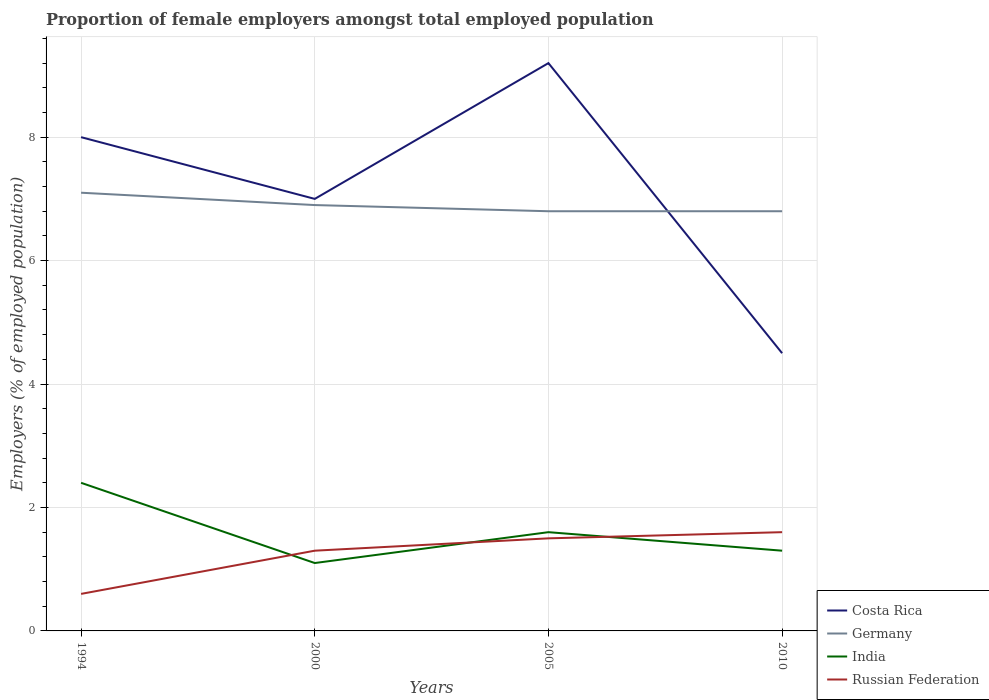How many different coloured lines are there?
Your answer should be compact. 4. Does the line corresponding to Costa Rica intersect with the line corresponding to Russian Federation?
Your response must be concise. No. Across all years, what is the maximum proportion of female employers in Costa Rica?
Ensure brevity in your answer.  4.5. In which year was the proportion of female employers in Germany maximum?
Your answer should be very brief. 2005. What is the total proportion of female employers in Russian Federation in the graph?
Your answer should be compact. -0.1. What is the difference between the highest and the second highest proportion of female employers in Germany?
Give a very brief answer. 0.3. Is the proportion of female employers in Russian Federation strictly greater than the proportion of female employers in Costa Rica over the years?
Offer a very short reply. Yes. How many lines are there?
Keep it short and to the point. 4. How many years are there in the graph?
Keep it short and to the point. 4. Are the values on the major ticks of Y-axis written in scientific E-notation?
Your answer should be compact. No. Does the graph contain any zero values?
Offer a terse response. No. Does the graph contain grids?
Provide a short and direct response. Yes. How many legend labels are there?
Your answer should be compact. 4. How are the legend labels stacked?
Your response must be concise. Vertical. What is the title of the graph?
Offer a very short reply. Proportion of female employers amongst total employed population. Does "Belarus" appear as one of the legend labels in the graph?
Your response must be concise. No. What is the label or title of the X-axis?
Your response must be concise. Years. What is the label or title of the Y-axis?
Make the answer very short. Employers (% of employed population). What is the Employers (% of employed population) in Costa Rica in 1994?
Your answer should be compact. 8. What is the Employers (% of employed population) of Germany in 1994?
Make the answer very short. 7.1. What is the Employers (% of employed population) in India in 1994?
Ensure brevity in your answer.  2.4. What is the Employers (% of employed population) of Russian Federation in 1994?
Offer a terse response. 0.6. What is the Employers (% of employed population) in Costa Rica in 2000?
Keep it short and to the point. 7. What is the Employers (% of employed population) of Germany in 2000?
Give a very brief answer. 6.9. What is the Employers (% of employed population) in India in 2000?
Give a very brief answer. 1.1. What is the Employers (% of employed population) of Russian Federation in 2000?
Keep it short and to the point. 1.3. What is the Employers (% of employed population) of Costa Rica in 2005?
Make the answer very short. 9.2. What is the Employers (% of employed population) of Germany in 2005?
Provide a short and direct response. 6.8. What is the Employers (% of employed population) of India in 2005?
Provide a short and direct response. 1.6. What is the Employers (% of employed population) of Russian Federation in 2005?
Your response must be concise. 1.5. What is the Employers (% of employed population) of Costa Rica in 2010?
Keep it short and to the point. 4.5. What is the Employers (% of employed population) of Germany in 2010?
Your response must be concise. 6.8. What is the Employers (% of employed population) of India in 2010?
Offer a very short reply. 1.3. What is the Employers (% of employed population) in Russian Federation in 2010?
Provide a succinct answer. 1.6. Across all years, what is the maximum Employers (% of employed population) in Costa Rica?
Ensure brevity in your answer.  9.2. Across all years, what is the maximum Employers (% of employed population) in Germany?
Provide a short and direct response. 7.1. Across all years, what is the maximum Employers (% of employed population) in India?
Provide a succinct answer. 2.4. Across all years, what is the maximum Employers (% of employed population) of Russian Federation?
Make the answer very short. 1.6. Across all years, what is the minimum Employers (% of employed population) of Germany?
Offer a very short reply. 6.8. Across all years, what is the minimum Employers (% of employed population) of India?
Make the answer very short. 1.1. Across all years, what is the minimum Employers (% of employed population) of Russian Federation?
Make the answer very short. 0.6. What is the total Employers (% of employed population) in Costa Rica in the graph?
Provide a succinct answer. 28.7. What is the total Employers (% of employed population) in Germany in the graph?
Ensure brevity in your answer.  27.6. What is the difference between the Employers (% of employed population) in Costa Rica in 1994 and that in 2000?
Keep it short and to the point. 1. What is the difference between the Employers (% of employed population) of Germany in 1994 and that in 2000?
Your response must be concise. 0.2. What is the difference between the Employers (% of employed population) in Costa Rica in 1994 and that in 2005?
Your answer should be very brief. -1.2. What is the difference between the Employers (% of employed population) in Germany in 1994 and that in 2005?
Keep it short and to the point. 0.3. What is the difference between the Employers (% of employed population) of India in 1994 and that in 2005?
Keep it short and to the point. 0.8. What is the difference between the Employers (% of employed population) of Germany in 1994 and that in 2010?
Make the answer very short. 0.3. What is the difference between the Employers (% of employed population) of Russian Federation in 1994 and that in 2010?
Your answer should be compact. -1. What is the difference between the Employers (% of employed population) of Costa Rica in 2000 and that in 2005?
Your answer should be compact. -2.2. What is the difference between the Employers (% of employed population) in Germany in 2000 and that in 2005?
Your answer should be compact. 0.1. What is the difference between the Employers (% of employed population) in Russian Federation in 2000 and that in 2005?
Your response must be concise. -0.2. What is the difference between the Employers (% of employed population) in Costa Rica in 2000 and that in 2010?
Offer a terse response. 2.5. What is the difference between the Employers (% of employed population) of India in 2000 and that in 2010?
Your answer should be very brief. -0.2. What is the difference between the Employers (% of employed population) of Costa Rica in 2005 and that in 2010?
Make the answer very short. 4.7. What is the difference between the Employers (% of employed population) of Germany in 2005 and that in 2010?
Offer a very short reply. 0. What is the difference between the Employers (% of employed population) in India in 2005 and that in 2010?
Offer a terse response. 0.3. What is the difference between the Employers (% of employed population) in Russian Federation in 2005 and that in 2010?
Provide a short and direct response. -0.1. What is the difference between the Employers (% of employed population) of Germany in 1994 and the Employers (% of employed population) of India in 2000?
Provide a short and direct response. 6. What is the difference between the Employers (% of employed population) of India in 1994 and the Employers (% of employed population) of Russian Federation in 2000?
Offer a terse response. 1.1. What is the difference between the Employers (% of employed population) of Costa Rica in 1994 and the Employers (% of employed population) of Germany in 2005?
Offer a terse response. 1.2. What is the difference between the Employers (% of employed population) in Germany in 1994 and the Employers (% of employed population) in India in 2005?
Keep it short and to the point. 5.5. What is the difference between the Employers (% of employed population) in India in 1994 and the Employers (% of employed population) in Russian Federation in 2005?
Offer a terse response. 0.9. What is the difference between the Employers (% of employed population) in Costa Rica in 2000 and the Employers (% of employed population) in Germany in 2005?
Offer a very short reply. 0.2. What is the difference between the Employers (% of employed population) in Costa Rica in 2000 and the Employers (% of employed population) in India in 2005?
Your answer should be very brief. 5.4. What is the difference between the Employers (% of employed population) of Costa Rica in 2000 and the Employers (% of employed population) of Russian Federation in 2005?
Your answer should be very brief. 5.5. What is the difference between the Employers (% of employed population) in Germany in 2000 and the Employers (% of employed population) in Russian Federation in 2010?
Make the answer very short. 5.3. What is the difference between the Employers (% of employed population) of India in 2000 and the Employers (% of employed population) of Russian Federation in 2010?
Give a very brief answer. -0.5. What is the difference between the Employers (% of employed population) of Germany in 2005 and the Employers (% of employed population) of Russian Federation in 2010?
Provide a short and direct response. 5.2. What is the average Employers (% of employed population) of Costa Rica per year?
Provide a short and direct response. 7.17. What is the average Employers (% of employed population) in India per year?
Keep it short and to the point. 1.6. In the year 1994, what is the difference between the Employers (% of employed population) in Costa Rica and Employers (% of employed population) in Germany?
Your response must be concise. 0.9. In the year 1994, what is the difference between the Employers (% of employed population) of Costa Rica and Employers (% of employed population) of India?
Keep it short and to the point. 5.6. In the year 1994, what is the difference between the Employers (% of employed population) of Germany and Employers (% of employed population) of India?
Your response must be concise. 4.7. In the year 1994, what is the difference between the Employers (% of employed population) of India and Employers (% of employed population) of Russian Federation?
Give a very brief answer. 1.8. In the year 2000, what is the difference between the Employers (% of employed population) in Costa Rica and Employers (% of employed population) in Russian Federation?
Provide a succinct answer. 5.7. In the year 2000, what is the difference between the Employers (% of employed population) in Germany and Employers (% of employed population) in Russian Federation?
Offer a very short reply. 5.6. In the year 2000, what is the difference between the Employers (% of employed population) in India and Employers (% of employed population) in Russian Federation?
Give a very brief answer. -0.2. In the year 2005, what is the difference between the Employers (% of employed population) of Costa Rica and Employers (% of employed population) of Russian Federation?
Offer a terse response. 7.7. In the year 2005, what is the difference between the Employers (% of employed population) in Germany and Employers (% of employed population) in Russian Federation?
Give a very brief answer. 5.3. In the year 2010, what is the difference between the Employers (% of employed population) in Costa Rica and Employers (% of employed population) in India?
Provide a succinct answer. 3.2. In the year 2010, what is the difference between the Employers (% of employed population) of Germany and Employers (% of employed population) of India?
Your response must be concise. 5.5. In the year 2010, what is the difference between the Employers (% of employed population) in Germany and Employers (% of employed population) in Russian Federation?
Provide a short and direct response. 5.2. In the year 2010, what is the difference between the Employers (% of employed population) in India and Employers (% of employed population) in Russian Federation?
Give a very brief answer. -0.3. What is the ratio of the Employers (% of employed population) of Germany in 1994 to that in 2000?
Ensure brevity in your answer.  1.03. What is the ratio of the Employers (% of employed population) of India in 1994 to that in 2000?
Ensure brevity in your answer.  2.18. What is the ratio of the Employers (% of employed population) in Russian Federation in 1994 to that in 2000?
Keep it short and to the point. 0.46. What is the ratio of the Employers (% of employed population) in Costa Rica in 1994 to that in 2005?
Offer a very short reply. 0.87. What is the ratio of the Employers (% of employed population) in Germany in 1994 to that in 2005?
Your response must be concise. 1.04. What is the ratio of the Employers (% of employed population) of India in 1994 to that in 2005?
Offer a terse response. 1.5. What is the ratio of the Employers (% of employed population) of Russian Federation in 1994 to that in 2005?
Ensure brevity in your answer.  0.4. What is the ratio of the Employers (% of employed population) in Costa Rica in 1994 to that in 2010?
Offer a terse response. 1.78. What is the ratio of the Employers (% of employed population) in Germany in 1994 to that in 2010?
Give a very brief answer. 1.04. What is the ratio of the Employers (% of employed population) in India in 1994 to that in 2010?
Keep it short and to the point. 1.85. What is the ratio of the Employers (% of employed population) in Costa Rica in 2000 to that in 2005?
Your response must be concise. 0.76. What is the ratio of the Employers (% of employed population) in Germany in 2000 to that in 2005?
Provide a short and direct response. 1.01. What is the ratio of the Employers (% of employed population) in India in 2000 to that in 2005?
Keep it short and to the point. 0.69. What is the ratio of the Employers (% of employed population) of Russian Federation in 2000 to that in 2005?
Offer a very short reply. 0.87. What is the ratio of the Employers (% of employed population) in Costa Rica in 2000 to that in 2010?
Offer a very short reply. 1.56. What is the ratio of the Employers (% of employed population) of Germany in 2000 to that in 2010?
Your answer should be compact. 1.01. What is the ratio of the Employers (% of employed population) in India in 2000 to that in 2010?
Offer a terse response. 0.85. What is the ratio of the Employers (% of employed population) of Russian Federation in 2000 to that in 2010?
Give a very brief answer. 0.81. What is the ratio of the Employers (% of employed population) of Costa Rica in 2005 to that in 2010?
Your answer should be compact. 2.04. What is the ratio of the Employers (% of employed population) in Germany in 2005 to that in 2010?
Offer a terse response. 1. What is the ratio of the Employers (% of employed population) of India in 2005 to that in 2010?
Your answer should be very brief. 1.23. What is the ratio of the Employers (% of employed population) of Russian Federation in 2005 to that in 2010?
Ensure brevity in your answer.  0.94. What is the difference between the highest and the second highest Employers (% of employed population) in Costa Rica?
Keep it short and to the point. 1.2. What is the difference between the highest and the second highest Employers (% of employed population) in Germany?
Provide a short and direct response. 0.2. What is the difference between the highest and the lowest Employers (% of employed population) of Costa Rica?
Ensure brevity in your answer.  4.7. What is the difference between the highest and the lowest Employers (% of employed population) in Germany?
Your response must be concise. 0.3. What is the difference between the highest and the lowest Employers (% of employed population) in India?
Give a very brief answer. 1.3. What is the difference between the highest and the lowest Employers (% of employed population) of Russian Federation?
Offer a terse response. 1. 